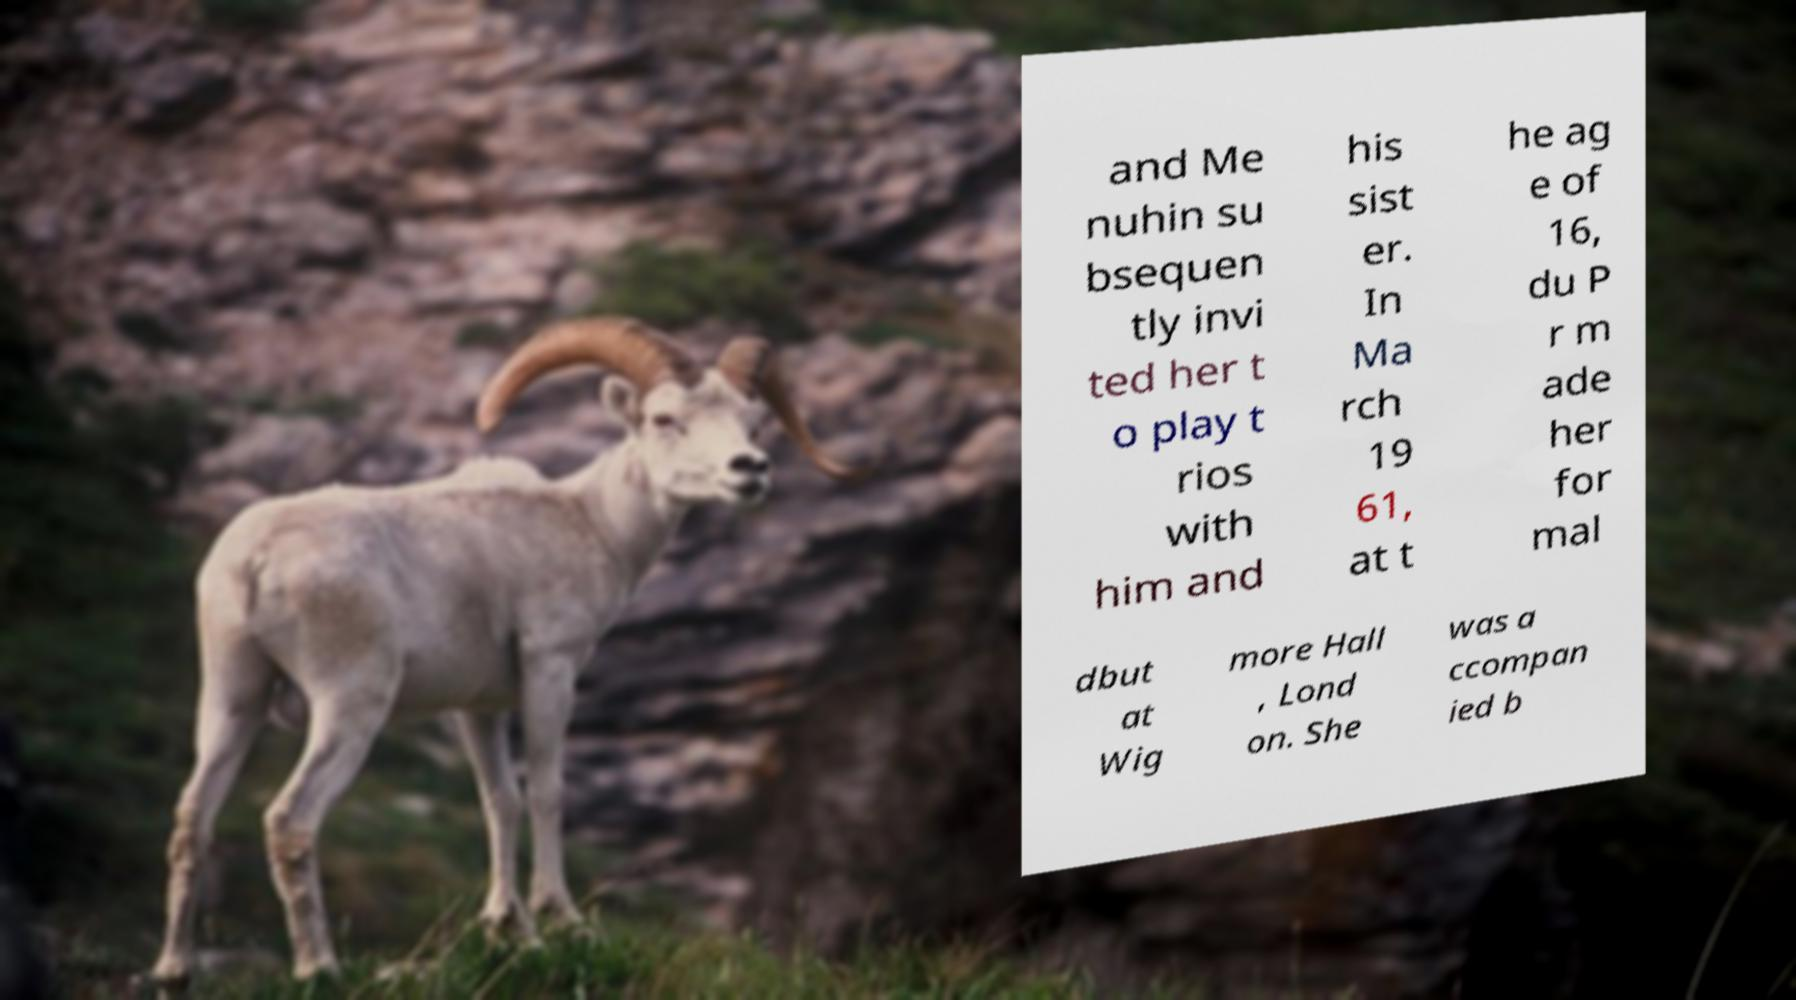Can you read and provide the text displayed in the image?This photo seems to have some interesting text. Can you extract and type it out for me? and Me nuhin su bsequen tly invi ted her t o play t rios with him and his sist er. In Ma rch 19 61, at t he ag e of 16, du P r m ade her for mal dbut at Wig more Hall , Lond on. She was a ccompan ied b 